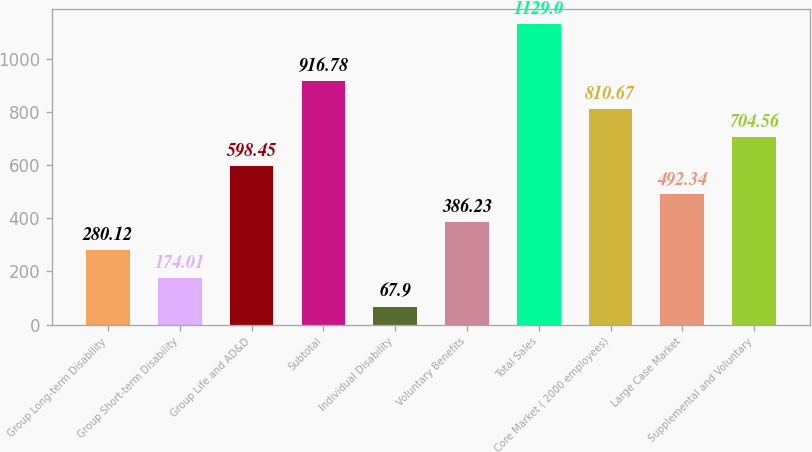Convert chart. <chart><loc_0><loc_0><loc_500><loc_500><bar_chart><fcel>Group Long-term Disability<fcel>Group Short-term Disability<fcel>Group Life and AD&D<fcel>Subtotal<fcel>Individual Disability<fcel>Voluntary Benefits<fcel>Total Sales<fcel>Core Market ( 2000 employees)<fcel>Large Case Market<fcel>Supplemental and Voluntary<nl><fcel>280.12<fcel>174.01<fcel>598.45<fcel>916.78<fcel>67.9<fcel>386.23<fcel>1129<fcel>810.67<fcel>492.34<fcel>704.56<nl></chart> 